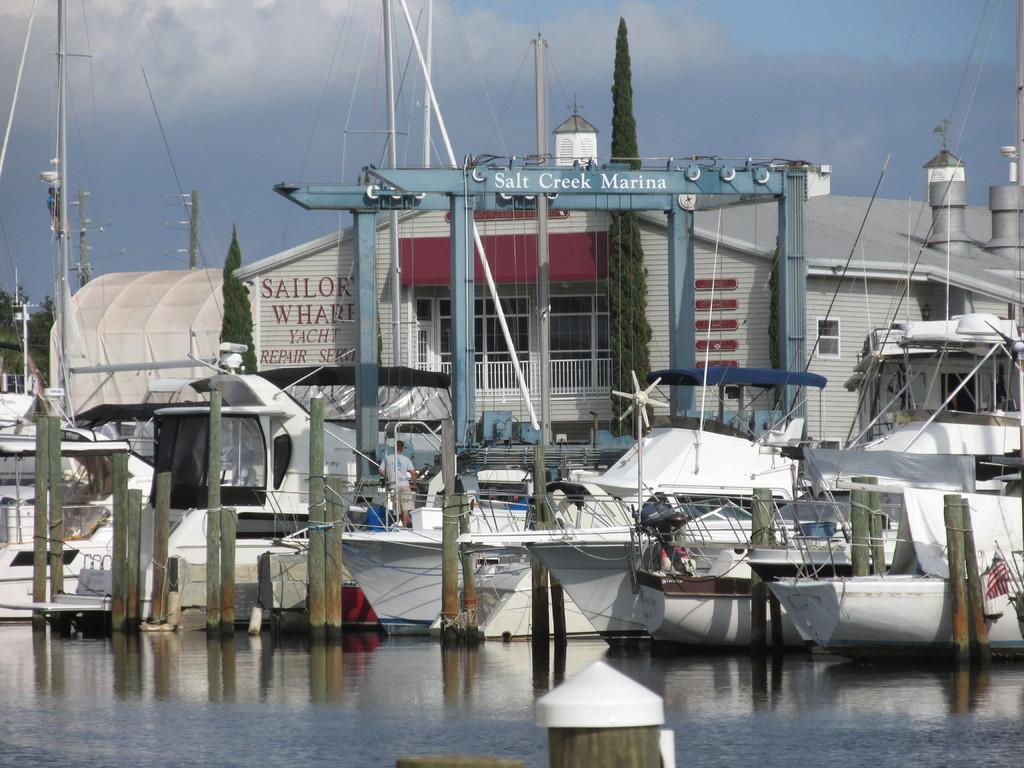<image>
Describe the image concisely. Boats are lined up in the water at Salt Creek Marina 